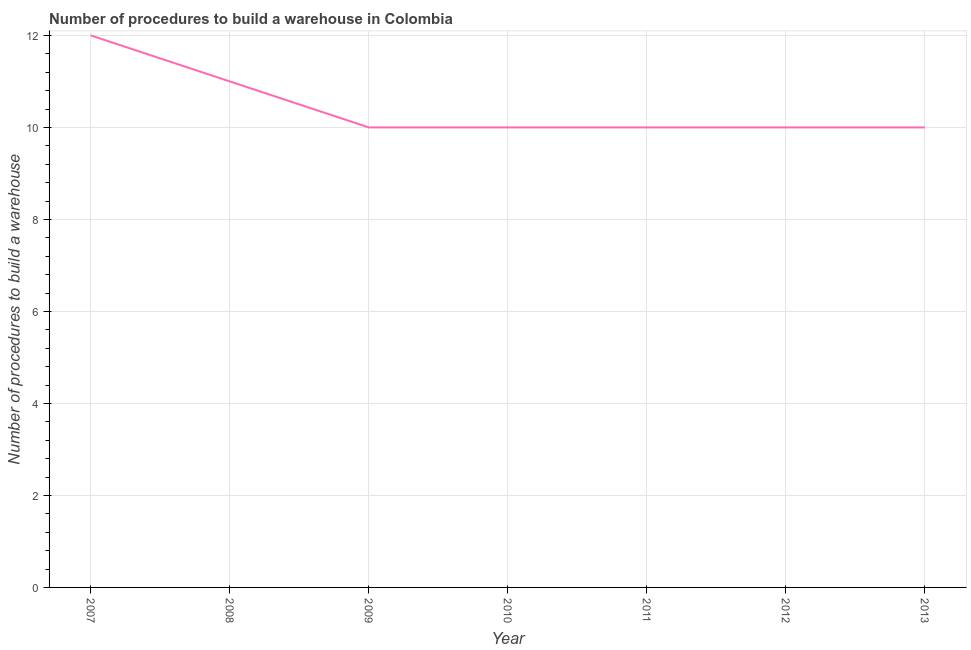What is the number of procedures to build a warehouse in 2008?
Make the answer very short. 11. Across all years, what is the maximum number of procedures to build a warehouse?
Your answer should be compact. 12. Across all years, what is the minimum number of procedures to build a warehouse?
Offer a terse response. 10. In which year was the number of procedures to build a warehouse maximum?
Your answer should be very brief. 2007. What is the sum of the number of procedures to build a warehouse?
Offer a very short reply. 73. What is the average number of procedures to build a warehouse per year?
Offer a very short reply. 10.43. Do a majority of the years between 2013 and 2012 (inclusive) have number of procedures to build a warehouse greater than 7.6 ?
Make the answer very short. No. Is the difference between the number of procedures to build a warehouse in 2007 and 2008 greater than the difference between any two years?
Your answer should be compact. No. What is the difference between the highest and the second highest number of procedures to build a warehouse?
Give a very brief answer. 1. What is the difference between the highest and the lowest number of procedures to build a warehouse?
Your answer should be very brief. 2. In how many years, is the number of procedures to build a warehouse greater than the average number of procedures to build a warehouse taken over all years?
Provide a short and direct response. 2. Does the number of procedures to build a warehouse monotonically increase over the years?
Offer a very short reply. No. How many years are there in the graph?
Offer a very short reply. 7. What is the difference between two consecutive major ticks on the Y-axis?
Keep it short and to the point. 2. Does the graph contain any zero values?
Offer a very short reply. No. What is the title of the graph?
Offer a very short reply. Number of procedures to build a warehouse in Colombia. What is the label or title of the Y-axis?
Make the answer very short. Number of procedures to build a warehouse. What is the Number of procedures to build a warehouse in 2008?
Provide a short and direct response. 11. What is the Number of procedures to build a warehouse in 2009?
Give a very brief answer. 10. What is the Number of procedures to build a warehouse of 2010?
Offer a terse response. 10. What is the Number of procedures to build a warehouse in 2011?
Your answer should be compact. 10. What is the Number of procedures to build a warehouse of 2013?
Give a very brief answer. 10. What is the difference between the Number of procedures to build a warehouse in 2007 and 2008?
Your answer should be compact. 1. What is the difference between the Number of procedures to build a warehouse in 2007 and 2011?
Ensure brevity in your answer.  2. What is the difference between the Number of procedures to build a warehouse in 2007 and 2013?
Your answer should be very brief. 2. What is the difference between the Number of procedures to build a warehouse in 2008 and 2011?
Offer a very short reply. 1. What is the difference between the Number of procedures to build a warehouse in 2008 and 2013?
Provide a short and direct response. 1. What is the difference between the Number of procedures to build a warehouse in 2009 and 2010?
Provide a succinct answer. 0. What is the difference between the Number of procedures to build a warehouse in 2009 and 2011?
Offer a very short reply. 0. What is the difference between the Number of procedures to build a warehouse in 2010 and 2011?
Offer a terse response. 0. What is the difference between the Number of procedures to build a warehouse in 2011 and 2013?
Ensure brevity in your answer.  0. What is the difference between the Number of procedures to build a warehouse in 2012 and 2013?
Your answer should be very brief. 0. What is the ratio of the Number of procedures to build a warehouse in 2007 to that in 2008?
Your answer should be very brief. 1.09. What is the ratio of the Number of procedures to build a warehouse in 2007 to that in 2009?
Make the answer very short. 1.2. What is the ratio of the Number of procedures to build a warehouse in 2007 to that in 2010?
Ensure brevity in your answer.  1.2. What is the ratio of the Number of procedures to build a warehouse in 2007 to that in 2011?
Make the answer very short. 1.2. What is the ratio of the Number of procedures to build a warehouse in 2007 to that in 2013?
Your answer should be compact. 1.2. What is the ratio of the Number of procedures to build a warehouse in 2008 to that in 2009?
Give a very brief answer. 1.1. What is the ratio of the Number of procedures to build a warehouse in 2008 to that in 2010?
Your response must be concise. 1.1. What is the ratio of the Number of procedures to build a warehouse in 2008 to that in 2011?
Provide a short and direct response. 1.1. What is the ratio of the Number of procedures to build a warehouse in 2008 to that in 2013?
Offer a very short reply. 1.1. What is the ratio of the Number of procedures to build a warehouse in 2009 to that in 2012?
Offer a terse response. 1. What is the ratio of the Number of procedures to build a warehouse in 2009 to that in 2013?
Your response must be concise. 1. What is the ratio of the Number of procedures to build a warehouse in 2010 to that in 2011?
Your response must be concise. 1. What is the ratio of the Number of procedures to build a warehouse in 2011 to that in 2012?
Your response must be concise. 1. What is the ratio of the Number of procedures to build a warehouse in 2011 to that in 2013?
Offer a very short reply. 1. What is the ratio of the Number of procedures to build a warehouse in 2012 to that in 2013?
Provide a short and direct response. 1. 